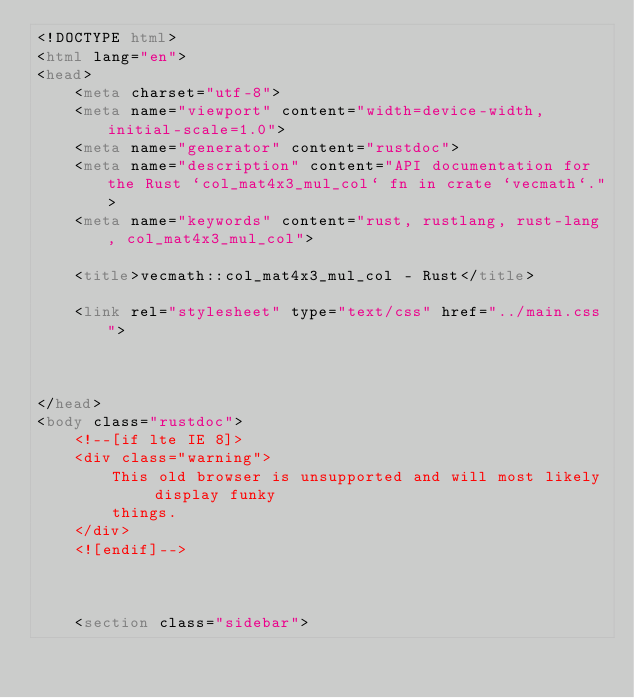Convert code to text. <code><loc_0><loc_0><loc_500><loc_500><_HTML_><!DOCTYPE html>
<html lang="en">
<head>
    <meta charset="utf-8">
    <meta name="viewport" content="width=device-width, initial-scale=1.0">
    <meta name="generator" content="rustdoc">
    <meta name="description" content="API documentation for the Rust `col_mat4x3_mul_col` fn in crate `vecmath`.">
    <meta name="keywords" content="rust, rustlang, rust-lang, col_mat4x3_mul_col">

    <title>vecmath::col_mat4x3_mul_col - Rust</title>

    <link rel="stylesheet" type="text/css" href="../main.css">

    
    
</head>
<body class="rustdoc">
    <!--[if lte IE 8]>
    <div class="warning">
        This old browser is unsupported and will most likely display funky
        things.
    </div>
    <![endif]-->

    

    <section class="sidebar">
        </code> 